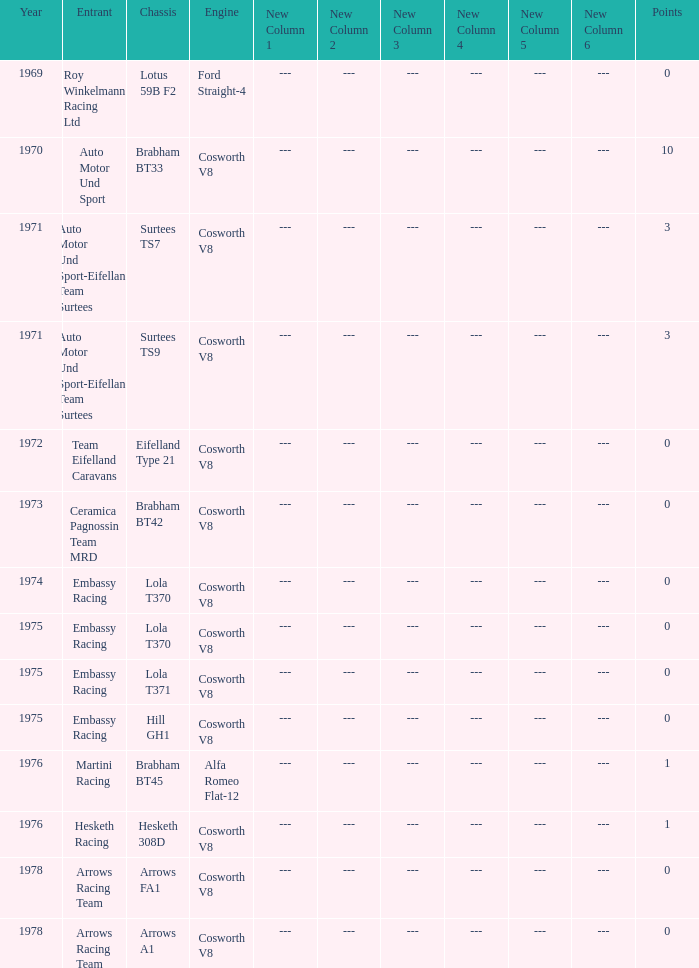What was the total amount of points in 1978 with a Chassis of arrows fa1? 0.0. 